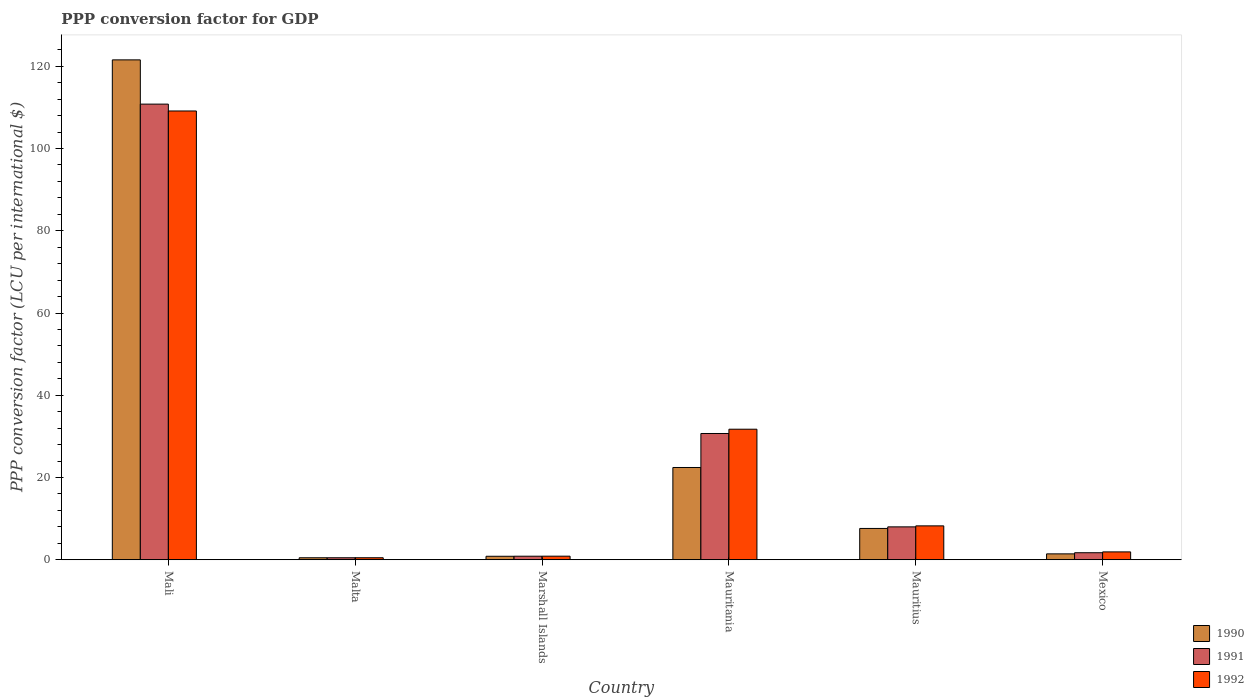How many different coloured bars are there?
Offer a terse response. 3. Are the number of bars on each tick of the X-axis equal?
Your answer should be very brief. Yes. What is the label of the 3rd group of bars from the left?
Your answer should be very brief. Marshall Islands. What is the PPP conversion factor for GDP in 1991 in Mauritius?
Ensure brevity in your answer.  8. Across all countries, what is the maximum PPP conversion factor for GDP in 1991?
Offer a very short reply. 110.8. Across all countries, what is the minimum PPP conversion factor for GDP in 1992?
Offer a very short reply. 0.49. In which country was the PPP conversion factor for GDP in 1992 maximum?
Your answer should be very brief. Mali. In which country was the PPP conversion factor for GDP in 1991 minimum?
Give a very brief answer. Malta. What is the total PPP conversion factor for GDP in 1991 in the graph?
Your answer should be compact. 152.57. What is the difference between the PPP conversion factor for GDP in 1992 in Malta and that in Mauritius?
Provide a short and direct response. -7.75. What is the difference between the PPP conversion factor for GDP in 1990 in Malta and the PPP conversion factor for GDP in 1992 in Mauritania?
Provide a short and direct response. -31.26. What is the average PPP conversion factor for GDP in 1991 per country?
Make the answer very short. 25.43. What is the difference between the PPP conversion factor for GDP of/in 1992 and PPP conversion factor for GDP of/in 1991 in Marshall Islands?
Offer a terse response. 0.01. In how many countries, is the PPP conversion factor for GDP in 1990 greater than 28 LCU?
Keep it short and to the point. 1. What is the ratio of the PPP conversion factor for GDP in 1991 in Malta to that in Marshall Islands?
Your response must be concise. 0.56. Is the difference between the PPP conversion factor for GDP in 1992 in Marshall Islands and Mauritania greater than the difference between the PPP conversion factor for GDP in 1991 in Marshall Islands and Mauritania?
Provide a succinct answer. No. What is the difference between the highest and the second highest PPP conversion factor for GDP in 1992?
Provide a short and direct response. -100.89. What is the difference between the highest and the lowest PPP conversion factor for GDP in 1990?
Keep it short and to the point. 121.08. Is the sum of the PPP conversion factor for GDP in 1992 in Marshall Islands and Mauritius greater than the maximum PPP conversion factor for GDP in 1990 across all countries?
Ensure brevity in your answer.  No. Is it the case that in every country, the sum of the PPP conversion factor for GDP in 1991 and PPP conversion factor for GDP in 1992 is greater than the PPP conversion factor for GDP in 1990?
Your response must be concise. Yes. How many bars are there?
Offer a terse response. 18. How many countries are there in the graph?
Keep it short and to the point. 6. Are the values on the major ticks of Y-axis written in scientific E-notation?
Your response must be concise. No. How many legend labels are there?
Provide a short and direct response. 3. How are the legend labels stacked?
Your answer should be compact. Vertical. What is the title of the graph?
Keep it short and to the point. PPP conversion factor for GDP. Does "1987" appear as one of the legend labels in the graph?
Provide a succinct answer. No. What is the label or title of the X-axis?
Your answer should be compact. Country. What is the label or title of the Y-axis?
Offer a terse response. PPP conversion factor (LCU per international $). What is the PPP conversion factor (LCU per international $) of 1990 in Mali?
Provide a short and direct response. 121.56. What is the PPP conversion factor (LCU per international $) of 1991 in Mali?
Offer a terse response. 110.8. What is the PPP conversion factor (LCU per international $) of 1992 in Mali?
Provide a succinct answer. 109.13. What is the PPP conversion factor (LCU per international $) in 1990 in Malta?
Provide a short and direct response. 0.49. What is the PPP conversion factor (LCU per international $) in 1991 in Malta?
Offer a terse response. 0.49. What is the PPP conversion factor (LCU per international $) of 1992 in Malta?
Your answer should be compact. 0.49. What is the PPP conversion factor (LCU per international $) in 1990 in Marshall Islands?
Your answer should be compact. 0.85. What is the PPP conversion factor (LCU per international $) in 1991 in Marshall Islands?
Offer a terse response. 0.86. What is the PPP conversion factor (LCU per international $) in 1992 in Marshall Islands?
Provide a succinct answer. 0.87. What is the PPP conversion factor (LCU per international $) of 1990 in Mauritania?
Offer a terse response. 22.44. What is the PPP conversion factor (LCU per international $) in 1991 in Mauritania?
Ensure brevity in your answer.  30.71. What is the PPP conversion factor (LCU per international $) of 1992 in Mauritania?
Make the answer very short. 31.75. What is the PPP conversion factor (LCU per international $) of 1990 in Mauritius?
Keep it short and to the point. 7.62. What is the PPP conversion factor (LCU per international $) of 1991 in Mauritius?
Your answer should be compact. 8. What is the PPP conversion factor (LCU per international $) of 1992 in Mauritius?
Your answer should be very brief. 8.24. What is the PPP conversion factor (LCU per international $) in 1990 in Mexico?
Provide a short and direct response. 1.43. What is the PPP conversion factor (LCU per international $) in 1991 in Mexico?
Your answer should be compact. 1.71. What is the PPP conversion factor (LCU per international $) in 1992 in Mexico?
Keep it short and to the point. 1.91. Across all countries, what is the maximum PPP conversion factor (LCU per international $) in 1990?
Keep it short and to the point. 121.56. Across all countries, what is the maximum PPP conversion factor (LCU per international $) of 1991?
Provide a succinct answer. 110.8. Across all countries, what is the maximum PPP conversion factor (LCU per international $) of 1992?
Your answer should be very brief. 109.13. Across all countries, what is the minimum PPP conversion factor (LCU per international $) in 1990?
Give a very brief answer. 0.49. Across all countries, what is the minimum PPP conversion factor (LCU per international $) of 1991?
Your answer should be very brief. 0.49. Across all countries, what is the minimum PPP conversion factor (LCU per international $) in 1992?
Ensure brevity in your answer.  0.49. What is the total PPP conversion factor (LCU per international $) in 1990 in the graph?
Ensure brevity in your answer.  154.38. What is the total PPP conversion factor (LCU per international $) of 1991 in the graph?
Offer a very short reply. 152.57. What is the total PPP conversion factor (LCU per international $) in 1992 in the graph?
Make the answer very short. 152.4. What is the difference between the PPP conversion factor (LCU per international $) of 1990 in Mali and that in Malta?
Your answer should be very brief. 121.08. What is the difference between the PPP conversion factor (LCU per international $) in 1991 in Mali and that in Malta?
Your answer should be compact. 110.32. What is the difference between the PPP conversion factor (LCU per international $) of 1992 in Mali and that in Malta?
Keep it short and to the point. 108.64. What is the difference between the PPP conversion factor (LCU per international $) in 1990 in Mali and that in Marshall Islands?
Keep it short and to the point. 120.71. What is the difference between the PPP conversion factor (LCU per international $) in 1991 in Mali and that in Marshall Islands?
Offer a very short reply. 109.94. What is the difference between the PPP conversion factor (LCU per international $) in 1992 in Mali and that in Marshall Islands?
Provide a succinct answer. 108.26. What is the difference between the PPP conversion factor (LCU per international $) of 1990 in Mali and that in Mauritania?
Give a very brief answer. 99.13. What is the difference between the PPP conversion factor (LCU per international $) in 1991 in Mali and that in Mauritania?
Give a very brief answer. 80.1. What is the difference between the PPP conversion factor (LCU per international $) in 1992 in Mali and that in Mauritania?
Provide a succinct answer. 77.39. What is the difference between the PPP conversion factor (LCU per international $) of 1990 in Mali and that in Mauritius?
Your response must be concise. 113.95. What is the difference between the PPP conversion factor (LCU per international $) in 1991 in Mali and that in Mauritius?
Your response must be concise. 102.8. What is the difference between the PPP conversion factor (LCU per international $) in 1992 in Mali and that in Mauritius?
Your answer should be compact. 100.89. What is the difference between the PPP conversion factor (LCU per international $) in 1990 in Mali and that in Mexico?
Provide a succinct answer. 120.13. What is the difference between the PPP conversion factor (LCU per international $) in 1991 in Mali and that in Mexico?
Give a very brief answer. 109.09. What is the difference between the PPP conversion factor (LCU per international $) in 1992 in Mali and that in Mexico?
Your answer should be very brief. 107.22. What is the difference between the PPP conversion factor (LCU per international $) in 1990 in Malta and that in Marshall Islands?
Offer a terse response. -0.36. What is the difference between the PPP conversion factor (LCU per international $) in 1991 in Malta and that in Marshall Islands?
Give a very brief answer. -0.38. What is the difference between the PPP conversion factor (LCU per international $) of 1992 in Malta and that in Marshall Islands?
Provide a short and direct response. -0.38. What is the difference between the PPP conversion factor (LCU per international $) of 1990 in Malta and that in Mauritania?
Keep it short and to the point. -21.95. What is the difference between the PPP conversion factor (LCU per international $) in 1991 in Malta and that in Mauritania?
Keep it short and to the point. -30.22. What is the difference between the PPP conversion factor (LCU per international $) in 1992 in Malta and that in Mauritania?
Provide a succinct answer. -31.25. What is the difference between the PPP conversion factor (LCU per international $) in 1990 in Malta and that in Mauritius?
Offer a very short reply. -7.13. What is the difference between the PPP conversion factor (LCU per international $) of 1991 in Malta and that in Mauritius?
Provide a short and direct response. -7.51. What is the difference between the PPP conversion factor (LCU per international $) of 1992 in Malta and that in Mauritius?
Your response must be concise. -7.75. What is the difference between the PPP conversion factor (LCU per international $) of 1990 in Malta and that in Mexico?
Keep it short and to the point. -0.95. What is the difference between the PPP conversion factor (LCU per international $) of 1991 in Malta and that in Mexico?
Make the answer very short. -1.22. What is the difference between the PPP conversion factor (LCU per international $) in 1992 in Malta and that in Mexico?
Your answer should be very brief. -1.42. What is the difference between the PPP conversion factor (LCU per international $) of 1990 in Marshall Islands and that in Mauritania?
Provide a succinct answer. -21.59. What is the difference between the PPP conversion factor (LCU per international $) in 1991 in Marshall Islands and that in Mauritania?
Your answer should be very brief. -29.84. What is the difference between the PPP conversion factor (LCU per international $) of 1992 in Marshall Islands and that in Mauritania?
Provide a succinct answer. -30.88. What is the difference between the PPP conversion factor (LCU per international $) of 1990 in Marshall Islands and that in Mauritius?
Keep it short and to the point. -6.77. What is the difference between the PPP conversion factor (LCU per international $) of 1991 in Marshall Islands and that in Mauritius?
Offer a terse response. -7.14. What is the difference between the PPP conversion factor (LCU per international $) in 1992 in Marshall Islands and that in Mauritius?
Your response must be concise. -7.37. What is the difference between the PPP conversion factor (LCU per international $) in 1990 in Marshall Islands and that in Mexico?
Offer a very short reply. -0.58. What is the difference between the PPP conversion factor (LCU per international $) in 1991 in Marshall Islands and that in Mexico?
Your response must be concise. -0.85. What is the difference between the PPP conversion factor (LCU per international $) of 1992 in Marshall Islands and that in Mexico?
Your answer should be compact. -1.04. What is the difference between the PPP conversion factor (LCU per international $) of 1990 in Mauritania and that in Mauritius?
Make the answer very short. 14.82. What is the difference between the PPP conversion factor (LCU per international $) in 1991 in Mauritania and that in Mauritius?
Your answer should be very brief. 22.7. What is the difference between the PPP conversion factor (LCU per international $) in 1992 in Mauritania and that in Mauritius?
Your response must be concise. 23.5. What is the difference between the PPP conversion factor (LCU per international $) of 1990 in Mauritania and that in Mexico?
Give a very brief answer. 21. What is the difference between the PPP conversion factor (LCU per international $) in 1991 in Mauritania and that in Mexico?
Your answer should be very brief. 29. What is the difference between the PPP conversion factor (LCU per international $) in 1992 in Mauritania and that in Mexico?
Your answer should be very brief. 29.83. What is the difference between the PPP conversion factor (LCU per international $) of 1990 in Mauritius and that in Mexico?
Ensure brevity in your answer.  6.18. What is the difference between the PPP conversion factor (LCU per international $) of 1991 in Mauritius and that in Mexico?
Your answer should be very brief. 6.29. What is the difference between the PPP conversion factor (LCU per international $) in 1992 in Mauritius and that in Mexico?
Provide a succinct answer. 6.33. What is the difference between the PPP conversion factor (LCU per international $) in 1990 in Mali and the PPP conversion factor (LCU per international $) in 1991 in Malta?
Your response must be concise. 121.08. What is the difference between the PPP conversion factor (LCU per international $) in 1990 in Mali and the PPP conversion factor (LCU per international $) in 1992 in Malta?
Make the answer very short. 121.07. What is the difference between the PPP conversion factor (LCU per international $) of 1991 in Mali and the PPP conversion factor (LCU per international $) of 1992 in Malta?
Your response must be concise. 110.31. What is the difference between the PPP conversion factor (LCU per international $) of 1990 in Mali and the PPP conversion factor (LCU per international $) of 1991 in Marshall Islands?
Your answer should be very brief. 120.7. What is the difference between the PPP conversion factor (LCU per international $) in 1990 in Mali and the PPP conversion factor (LCU per international $) in 1992 in Marshall Islands?
Offer a terse response. 120.69. What is the difference between the PPP conversion factor (LCU per international $) in 1991 in Mali and the PPP conversion factor (LCU per international $) in 1992 in Marshall Islands?
Ensure brevity in your answer.  109.93. What is the difference between the PPP conversion factor (LCU per international $) of 1990 in Mali and the PPP conversion factor (LCU per international $) of 1991 in Mauritania?
Give a very brief answer. 90.86. What is the difference between the PPP conversion factor (LCU per international $) of 1990 in Mali and the PPP conversion factor (LCU per international $) of 1992 in Mauritania?
Your answer should be compact. 89.82. What is the difference between the PPP conversion factor (LCU per international $) in 1991 in Mali and the PPP conversion factor (LCU per international $) in 1992 in Mauritania?
Your response must be concise. 79.06. What is the difference between the PPP conversion factor (LCU per international $) in 1990 in Mali and the PPP conversion factor (LCU per international $) in 1991 in Mauritius?
Your answer should be compact. 113.56. What is the difference between the PPP conversion factor (LCU per international $) in 1990 in Mali and the PPP conversion factor (LCU per international $) in 1992 in Mauritius?
Ensure brevity in your answer.  113.32. What is the difference between the PPP conversion factor (LCU per international $) of 1991 in Mali and the PPP conversion factor (LCU per international $) of 1992 in Mauritius?
Make the answer very short. 102.56. What is the difference between the PPP conversion factor (LCU per international $) of 1990 in Mali and the PPP conversion factor (LCU per international $) of 1991 in Mexico?
Make the answer very short. 119.85. What is the difference between the PPP conversion factor (LCU per international $) in 1990 in Mali and the PPP conversion factor (LCU per international $) in 1992 in Mexico?
Your response must be concise. 119.65. What is the difference between the PPP conversion factor (LCU per international $) of 1991 in Mali and the PPP conversion factor (LCU per international $) of 1992 in Mexico?
Offer a terse response. 108.89. What is the difference between the PPP conversion factor (LCU per international $) of 1990 in Malta and the PPP conversion factor (LCU per international $) of 1991 in Marshall Islands?
Keep it short and to the point. -0.38. What is the difference between the PPP conversion factor (LCU per international $) in 1990 in Malta and the PPP conversion factor (LCU per international $) in 1992 in Marshall Islands?
Provide a succinct answer. -0.38. What is the difference between the PPP conversion factor (LCU per international $) in 1991 in Malta and the PPP conversion factor (LCU per international $) in 1992 in Marshall Islands?
Your answer should be compact. -0.38. What is the difference between the PPP conversion factor (LCU per international $) of 1990 in Malta and the PPP conversion factor (LCU per international $) of 1991 in Mauritania?
Provide a short and direct response. -30.22. What is the difference between the PPP conversion factor (LCU per international $) in 1990 in Malta and the PPP conversion factor (LCU per international $) in 1992 in Mauritania?
Your answer should be very brief. -31.26. What is the difference between the PPP conversion factor (LCU per international $) in 1991 in Malta and the PPP conversion factor (LCU per international $) in 1992 in Mauritania?
Ensure brevity in your answer.  -31.26. What is the difference between the PPP conversion factor (LCU per international $) of 1990 in Malta and the PPP conversion factor (LCU per international $) of 1991 in Mauritius?
Provide a succinct answer. -7.51. What is the difference between the PPP conversion factor (LCU per international $) of 1990 in Malta and the PPP conversion factor (LCU per international $) of 1992 in Mauritius?
Offer a terse response. -7.76. What is the difference between the PPP conversion factor (LCU per international $) in 1991 in Malta and the PPP conversion factor (LCU per international $) in 1992 in Mauritius?
Your response must be concise. -7.76. What is the difference between the PPP conversion factor (LCU per international $) of 1990 in Malta and the PPP conversion factor (LCU per international $) of 1991 in Mexico?
Your answer should be compact. -1.22. What is the difference between the PPP conversion factor (LCU per international $) of 1990 in Malta and the PPP conversion factor (LCU per international $) of 1992 in Mexico?
Provide a short and direct response. -1.43. What is the difference between the PPP conversion factor (LCU per international $) in 1991 in Malta and the PPP conversion factor (LCU per international $) in 1992 in Mexico?
Make the answer very short. -1.43. What is the difference between the PPP conversion factor (LCU per international $) of 1990 in Marshall Islands and the PPP conversion factor (LCU per international $) of 1991 in Mauritania?
Give a very brief answer. -29.86. What is the difference between the PPP conversion factor (LCU per international $) of 1990 in Marshall Islands and the PPP conversion factor (LCU per international $) of 1992 in Mauritania?
Your answer should be compact. -30.9. What is the difference between the PPP conversion factor (LCU per international $) of 1991 in Marshall Islands and the PPP conversion factor (LCU per international $) of 1992 in Mauritania?
Ensure brevity in your answer.  -30.88. What is the difference between the PPP conversion factor (LCU per international $) in 1990 in Marshall Islands and the PPP conversion factor (LCU per international $) in 1991 in Mauritius?
Keep it short and to the point. -7.15. What is the difference between the PPP conversion factor (LCU per international $) in 1990 in Marshall Islands and the PPP conversion factor (LCU per international $) in 1992 in Mauritius?
Ensure brevity in your answer.  -7.39. What is the difference between the PPP conversion factor (LCU per international $) in 1991 in Marshall Islands and the PPP conversion factor (LCU per international $) in 1992 in Mauritius?
Offer a very short reply. -7.38. What is the difference between the PPP conversion factor (LCU per international $) of 1990 in Marshall Islands and the PPP conversion factor (LCU per international $) of 1991 in Mexico?
Offer a very short reply. -0.86. What is the difference between the PPP conversion factor (LCU per international $) in 1990 in Marshall Islands and the PPP conversion factor (LCU per international $) in 1992 in Mexico?
Your answer should be very brief. -1.06. What is the difference between the PPP conversion factor (LCU per international $) in 1991 in Marshall Islands and the PPP conversion factor (LCU per international $) in 1992 in Mexico?
Provide a succinct answer. -1.05. What is the difference between the PPP conversion factor (LCU per international $) in 1990 in Mauritania and the PPP conversion factor (LCU per international $) in 1991 in Mauritius?
Offer a very short reply. 14.44. What is the difference between the PPP conversion factor (LCU per international $) in 1990 in Mauritania and the PPP conversion factor (LCU per international $) in 1992 in Mauritius?
Offer a terse response. 14.19. What is the difference between the PPP conversion factor (LCU per international $) of 1991 in Mauritania and the PPP conversion factor (LCU per international $) of 1992 in Mauritius?
Keep it short and to the point. 22.46. What is the difference between the PPP conversion factor (LCU per international $) in 1990 in Mauritania and the PPP conversion factor (LCU per international $) in 1991 in Mexico?
Ensure brevity in your answer.  20.73. What is the difference between the PPP conversion factor (LCU per international $) in 1990 in Mauritania and the PPP conversion factor (LCU per international $) in 1992 in Mexico?
Give a very brief answer. 20.52. What is the difference between the PPP conversion factor (LCU per international $) of 1991 in Mauritania and the PPP conversion factor (LCU per international $) of 1992 in Mexico?
Offer a terse response. 28.79. What is the difference between the PPP conversion factor (LCU per international $) in 1990 in Mauritius and the PPP conversion factor (LCU per international $) in 1991 in Mexico?
Your answer should be very brief. 5.91. What is the difference between the PPP conversion factor (LCU per international $) in 1990 in Mauritius and the PPP conversion factor (LCU per international $) in 1992 in Mexico?
Your answer should be compact. 5.7. What is the difference between the PPP conversion factor (LCU per international $) in 1991 in Mauritius and the PPP conversion factor (LCU per international $) in 1992 in Mexico?
Offer a very short reply. 6.09. What is the average PPP conversion factor (LCU per international $) of 1990 per country?
Your response must be concise. 25.73. What is the average PPP conversion factor (LCU per international $) of 1991 per country?
Provide a short and direct response. 25.43. What is the average PPP conversion factor (LCU per international $) of 1992 per country?
Your answer should be compact. 25.4. What is the difference between the PPP conversion factor (LCU per international $) in 1990 and PPP conversion factor (LCU per international $) in 1991 in Mali?
Offer a terse response. 10.76. What is the difference between the PPP conversion factor (LCU per international $) of 1990 and PPP conversion factor (LCU per international $) of 1992 in Mali?
Provide a short and direct response. 12.43. What is the difference between the PPP conversion factor (LCU per international $) of 1991 and PPP conversion factor (LCU per international $) of 1992 in Mali?
Provide a short and direct response. 1.67. What is the difference between the PPP conversion factor (LCU per international $) in 1990 and PPP conversion factor (LCU per international $) in 1991 in Malta?
Keep it short and to the point. -0. What is the difference between the PPP conversion factor (LCU per international $) of 1990 and PPP conversion factor (LCU per international $) of 1992 in Malta?
Your response must be concise. -0.01. What is the difference between the PPP conversion factor (LCU per international $) of 1991 and PPP conversion factor (LCU per international $) of 1992 in Malta?
Provide a succinct answer. -0.01. What is the difference between the PPP conversion factor (LCU per international $) in 1990 and PPP conversion factor (LCU per international $) in 1991 in Marshall Islands?
Your answer should be very brief. -0.01. What is the difference between the PPP conversion factor (LCU per international $) in 1990 and PPP conversion factor (LCU per international $) in 1992 in Marshall Islands?
Offer a terse response. -0.02. What is the difference between the PPP conversion factor (LCU per international $) in 1991 and PPP conversion factor (LCU per international $) in 1992 in Marshall Islands?
Offer a terse response. -0.01. What is the difference between the PPP conversion factor (LCU per international $) of 1990 and PPP conversion factor (LCU per international $) of 1991 in Mauritania?
Your response must be concise. -8.27. What is the difference between the PPP conversion factor (LCU per international $) in 1990 and PPP conversion factor (LCU per international $) in 1992 in Mauritania?
Keep it short and to the point. -9.31. What is the difference between the PPP conversion factor (LCU per international $) in 1991 and PPP conversion factor (LCU per international $) in 1992 in Mauritania?
Ensure brevity in your answer.  -1.04. What is the difference between the PPP conversion factor (LCU per international $) of 1990 and PPP conversion factor (LCU per international $) of 1991 in Mauritius?
Your response must be concise. -0.39. What is the difference between the PPP conversion factor (LCU per international $) in 1990 and PPP conversion factor (LCU per international $) in 1992 in Mauritius?
Your response must be concise. -0.63. What is the difference between the PPP conversion factor (LCU per international $) in 1991 and PPP conversion factor (LCU per international $) in 1992 in Mauritius?
Give a very brief answer. -0.24. What is the difference between the PPP conversion factor (LCU per international $) in 1990 and PPP conversion factor (LCU per international $) in 1991 in Mexico?
Give a very brief answer. -0.28. What is the difference between the PPP conversion factor (LCU per international $) of 1990 and PPP conversion factor (LCU per international $) of 1992 in Mexico?
Provide a short and direct response. -0.48. What is the difference between the PPP conversion factor (LCU per international $) in 1991 and PPP conversion factor (LCU per international $) in 1992 in Mexico?
Offer a very short reply. -0.2. What is the ratio of the PPP conversion factor (LCU per international $) in 1990 in Mali to that in Malta?
Ensure brevity in your answer.  249.76. What is the ratio of the PPP conversion factor (LCU per international $) of 1991 in Mali to that in Malta?
Keep it short and to the point. 227.61. What is the ratio of the PPP conversion factor (LCU per international $) of 1992 in Mali to that in Malta?
Offer a terse response. 221.42. What is the ratio of the PPP conversion factor (LCU per international $) in 1990 in Mali to that in Marshall Islands?
Provide a short and direct response. 143.05. What is the ratio of the PPP conversion factor (LCU per international $) of 1991 in Mali to that in Marshall Islands?
Your answer should be very brief. 128.26. What is the ratio of the PPP conversion factor (LCU per international $) in 1992 in Mali to that in Marshall Islands?
Provide a short and direct response. 125.42. What is the ratio of the PPP conversion factor (LCU per international $) in 1990 in Mali to that in Mauritania?
Provide a short and direct response. 5.42. What is the ratio of the PPP conversion factor (LCU per international $) of 1991 in Mali to that in Mauritania?
Offer a very short reply. 3.61. What is the ratio of the PPP conversion factor (LCU per international $) in 1992 in Mali to that in Mauritania?
Your answer should be compact. 3.44. What is the ratio of the PPP conversion factor (LCU per international $) of 1990 in Mali to that in Mauritius?
Offer a terse response. 15.96. What is the ratio of the PPP conversion factor (LCU per international $) of 1991 in Mali to that in Mauritius?
Ensure brevity in your answer.  13.85. What is the ratio of the PPP conversion factor (LCU per international $) of 1992 in Mali to that in Mauritius?
Ensure brevity in your answer.  13.24. What is the ratio of the PPP conversion factor (LCU per international $) of 1990 in Mali to that in Mexico?
Offer a terse response. 84.78. What is the ratio of the PPP conversion factor (LCU per international $) of 1991 in Mali to that in Mexico?
Give a very brief answer. 64.78. What is the ratio of the PPP conversion factor (LCU per international $) in 1992 in Mali to that in Mexico?
Ensure brevity in your answer.  57.04. What is the ratio of the PPP conversion factor (LCU per international $) of 1990 in Malta to that in Marshall Islands?
Give a very brief answer. 0.57. What is the ratio of the PPP conversion factor (LCU per international $) of 1991 in Malta to that in Marshall Islands?
Ensure brevity in your answer.  0.56. What is the ratio of the PPP conversion factor (LCU per international $) in 1992 in Malta to that in Marshall Islands?
Provide a short and direct response. 0.57. What is the ratio of the PPP conversion factor (LCU per international $) of 1990 in Malta to that in Mauritania?
Ensure brevity in your answer.  0.02. What is the ratio of the PPP conversion factor (LCU per international $) in 1991 in Malta to that in Mauritania?
Make the answer very short. 0.02. What is the ratio of the PPP conversion factor (LCU per international $) in 1992 in Malta to that in Mauritania?
Offer a very short reply. 0.02. What is the ratio of the PPP conversion factor (LCU per international $) of 1990 in Malta to that in Mauritius?
Ensure brevity in your answer.  0.06. What is the ratio of the PPP conversion factor (LCU per international $) of 1991 in Malta to that in Mauritius?
Provide a succinct answer. 0.06. What is the ratio of the PPP conversion factor (LCU per international $) of 1992 in Malta to that in Mauritius?
Offer a terse response. 0.06. What is the ratio of the PPP conversion factor (LCU per international $) in 1990 in Malta to that in Mexico?
Provide a short and direct response. 0.34. What is the ratio of the PPP conversion factor (LCU per international $) of 1991 in Malta to that in Mexico?
Ensure brevity in your answer.  0.28. What is the ratio of the PPP conversion factor (LCU per international $) of 1992 in Malta to that in Mexico?
Offer a very short reply. 0.26. What is the ratio of the PPP conversion factor (LCU per international $) in 1990 in Marshall Islands to that in Mauritania?
Your answer should be compact. 0.04. What is the ratio of the PPP conversion factor (LCU per international $) of 1991 in Marshall Islands to that in Mauritania?
Keep it short and to the point. 0.03. What is the ratio of the PPP conversion factor (LCU per international $) of 1992 in Marshall Islands to that in Mauritania?
Make the answer very short. 0.03. What is the ratio of the PPP conversion factor (LCU per international $) in 1990 in Marshall Islands to that in Mauritius?
Give a very brief answer. 0.11. What is the ratio of the PPP conversion factor (LCU per international $) in 1991 in Marshall Islands to that in Mauritius?
Make the answer very short. 0.11. What is the ratio of the PPP conversion factor (LCU per international $) of 1992 in Marshall Islands to that in Mauritius?
Offer a very short reply. 0.11. What is the ratio of the PPP conversion factor (LCU per international $) in 1990 in Marshall Islands to that in Mexico?
Provide a succinct answer. 0.59. What is the ratio of the PPP conversion factor (LCU per international $) in 1991 in Marshall Islands to that in Mexico?
Your response must be concise. 0.51. What is the ratio of the PPP conversion factor (LCU per international $) in 1992 in Marshall Islands to that in Mexico?
Ensure brevity in your answer.  0.45. What is the ratio of the PPP conversion factor (LCU per international $) of 1990 in Mauritania to that in Mauritius?
Your answer should be very brief. 2.95. What is the ratio of the PPP conversion factor (LCU per international $) of 1991 in Mauritania to that in Mauritius?
Offer a terse response. 3.84. What is the ratio of the PPP conversion factor (LCU per international $) in 1992 in Mauritania to that in Mauritius?
Offer a terse response. 3.85. What is the ratio of the PPP conversion factor (LCU per international $) of 1990 in Mauritania to that in Mexico?
Provide a short and direct response. 15.65. What is the ratio of the PPP conversion factor (LCU per international $) in 1991 in Mauritania to that in Mexico?
Give a very brief answer. 17.95. What is the ratio of the PPP conversion factor (LCU per international $) in 1992 in Mauritania to that in Mexico?
Keep it short and to the point. 16.59. What is the ratio of the PPP conversion factor (LCU per international $) in 1990 in Mauritius to that in Mexico?
Your answer should be compact. 5.31. What is the ratio of the PPP conversion factor (LCU per international $) of 1991 in Mauritius to that in Mexico?
Offer a terse response. 4.68. What is the ratio of the PPP conversion factor (LCU per international $) in 1992 in Mauritius to that in Mexico?
Your answer should be very brief. 4.31. What is the difference between the highest and the second highest PPP conversion factor (LCU per international $) in 1990?
Provide a succinct answer. 99.13. What is the difference between the highest and the second highest PPP conversion factor (LCU per international $) in 1991?
Keep it short and to the point. 80.1. What is the difference between the highest and the second highest PPP conversion factor (LCU per international $) of 1992?
Offer a very short reply. 77.39. What is the difference between the highest and the lowest PPP conversion factor (LCU per international $) of 1990?
Your answer should be very brief. 121.08. What is the difference between the highest and the lowest PPP conversion factor (LCU per international $) in 1991?
Your response must be concise. 110.32. What is the difference between the highest and the lowest PPP conversion factor (LCU per international $) in 1992?
Offer a very short reply. 108.64. 